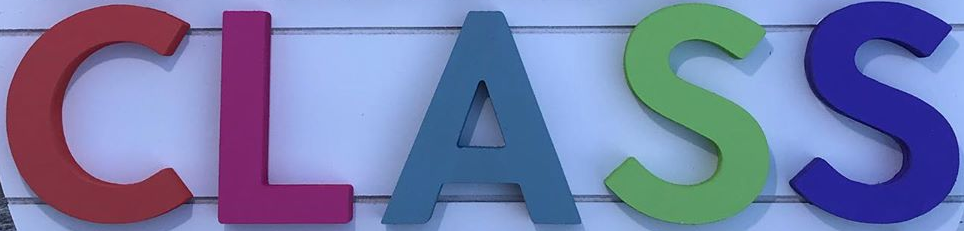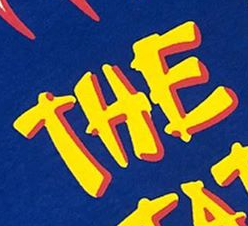Identify the words shown in these images in order, separated by a semicolon. CLASS; THE 